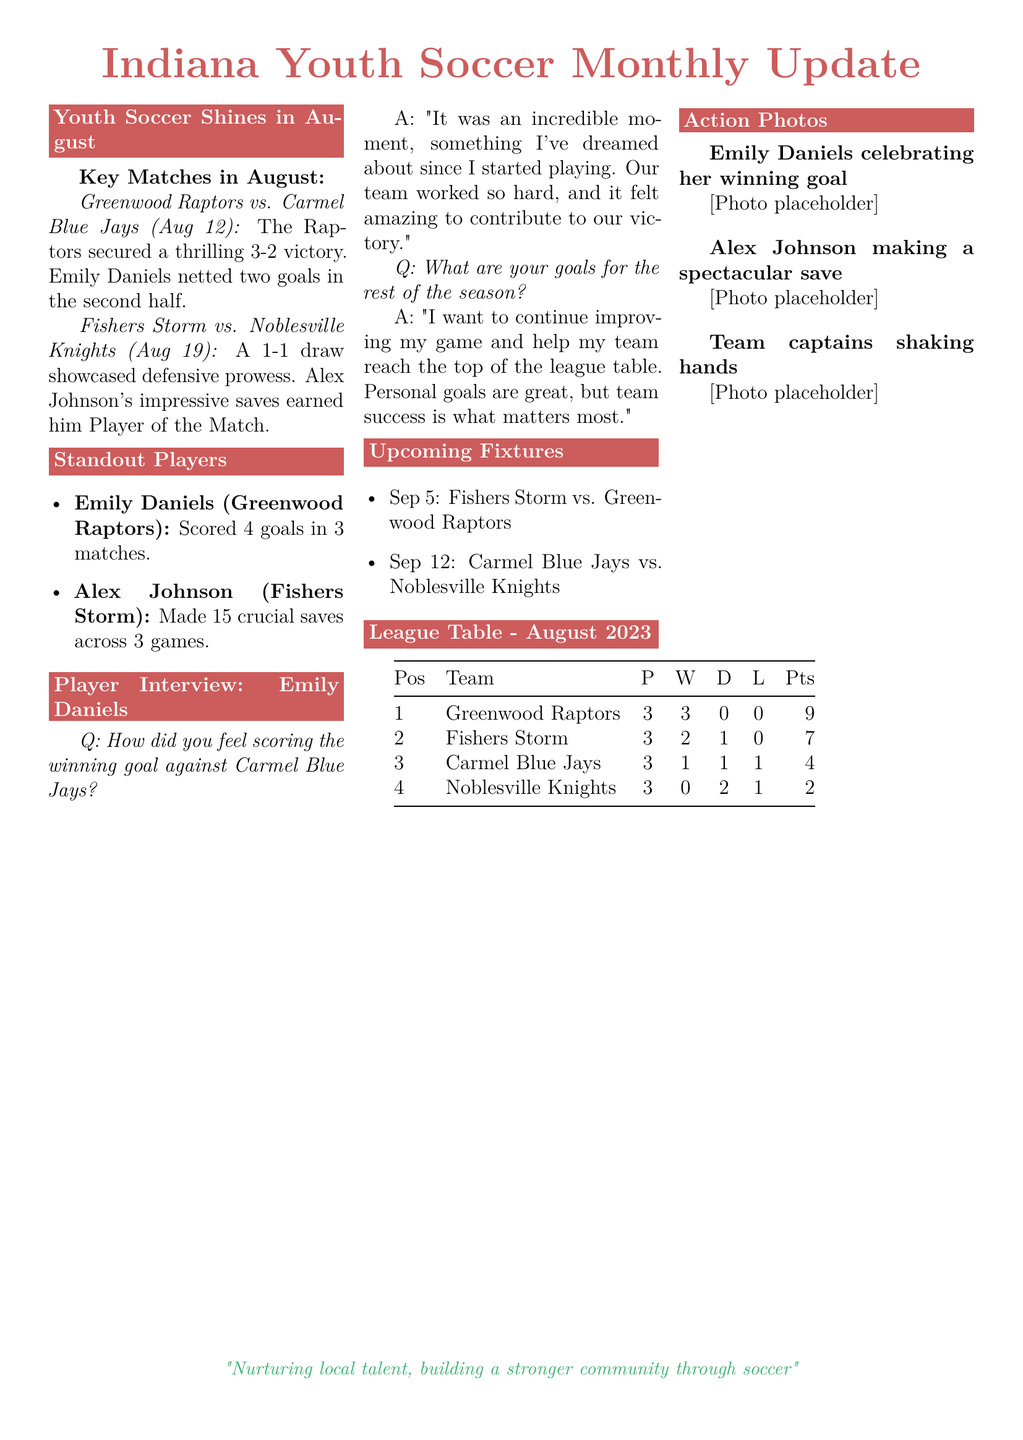What team won the match on August 12? The document states that the Greenwood Raptors secured a victory over the Carmel Blue Jays on August 12.
Answer: Greenwood Raptors How many goals did Emily Daniels score in August? The standout player section shows that Emily Daniels scored 4 goals in 3 matches in August.
Answer: 4 goals What position are the Noblesville Knights in the league table? The league table lists the Noblesville Knights in the 4th position.
Answer: 4 Who is the Player of the Match in the August 19 game? Alex Johnson earned the title of Player of the Match for his impressive performance in the game on August 19.
Answer: Alex Johnson What is the upcoming fixture on September 12? The document explicitly lists the match scheduled for September 12 as Carmel Blue Jays vs. Noblesville Knights.
Answer: Carmel Blue Jays vs. Noblesville Knights What was the total number of matches played by Greenwood Raptors? The league table indicates that Greenwood Raptors played a total of 3 matches.
Answer: 3 Which player made 15 saves in 3 games? The standout players section identifies Alex Johnson as the player who made 15 crucial saves across 3 games.
Answer: Alex Johnson What color are the headings of the sections? The document uses the color indianared for the section headings.
Answer: indianared 